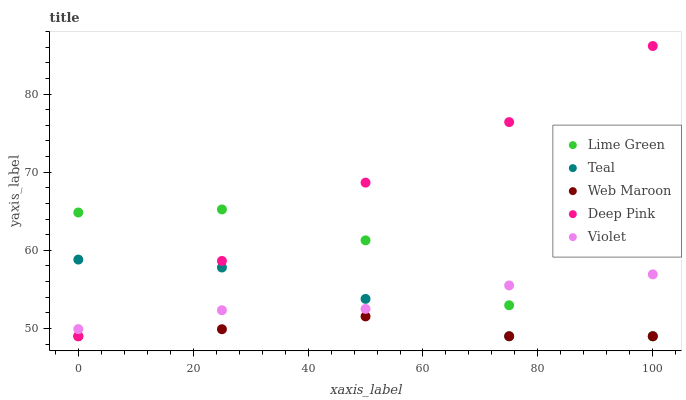Does Web Maroon have the minimum area under the curve?
Answer yes or no. Yes. Does Deep Pink have the maximum area under the curve?
Answer yes or no. Yes. Does Lime Green have the minimum area under the curve?
Answer yes or no. No. Does Lime Green have the maximum area under the curve?
Answer yes or no. No. Is Deep Pink the smoothest?
Answer yes or no. Yes. Is Lime Green the roughest?
Answer yes or no. Yes. Is Lime Green the smoothest?
Answer yes or no. No. Is Deep Pink the roughest?
Answer yes or no. No. Does Web Maroon have the lowest value?
Answer yes or no. Yes. Does Violet have the lowest value?
Answer yes or no. No. Does Deep Pink have the highest value?
Answer yes or no. Yes. Does Lime Green have the highest value?
Answer yes or no. No. Is Web Maroon less than Violet?
Answer yes or no. Yes. Is Violet greater than Web Maroon?
Answer yes or no. Yes. Does Web Maroon intersect Teal?
Answer yes or no. Yes. Is Web Maroon less than Teal?
Answer yes or no. No. Is Web Maroon greater than Teal?
Answer yes or no. No. Does Web Maroon intersect Violet?
Answer yes or no. No. 